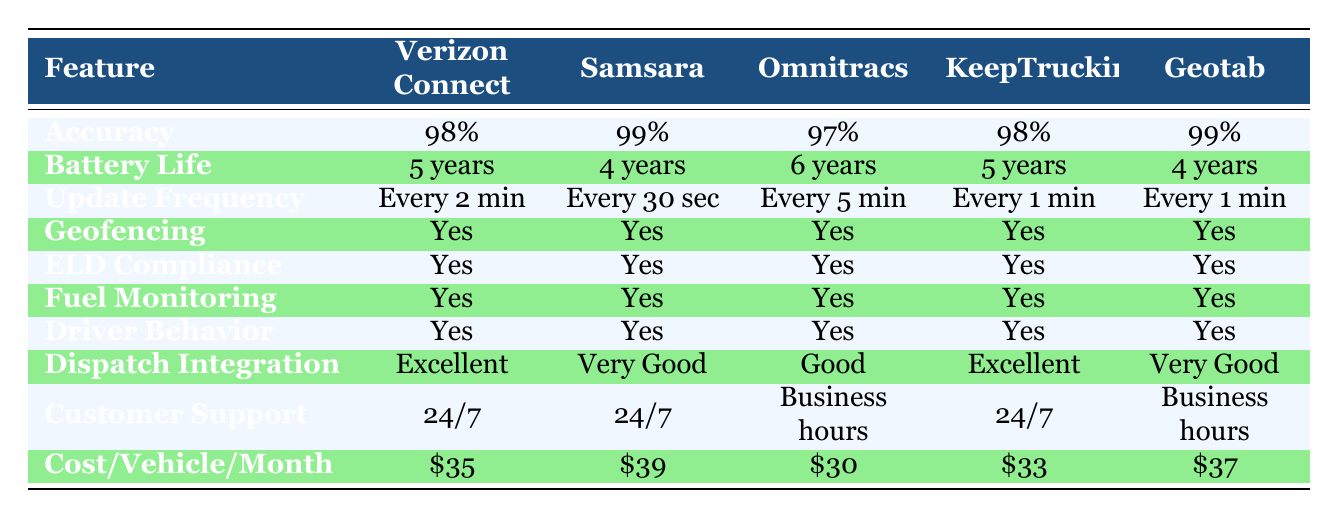What is the real-time tracking accuracy of Samsara? The table shows the real-time tracking accuracy for each GPS tracking system. Looking at the Samsara row, I see that its accuracy is listed as 99%.
Answer: 99% Which GPS system has the longest battery life? To determine which GPS system has the longest battery life, I compare the battery life values across all brands. The table shows that Omnitracs has a battery life of 6 years, which is longer than the others.
Answer: Omnitracs Is KeepTruckin ELD compliant? The table lists ELD compliance for each GPS tracking system. Looking at the KeepTruckin row, it states 'Yes' for ELD compliance, confirming it is compliant.
Answer: Yes Which GPS system provides updates every minute? By checking the update frequency for each GPS system, I can identify which ones provide updates every minute. The table shows that both KeepTruckin and Geotab have an update frequency of every 1 minute.
Answer: KeepTruckin and Geotab What is the cost per vehicle per month for the GPS system with the best customer support? I first locate the customer support quality for each system. The best quality is 'Excellent', found in the rows for Verizon Connect and KeepTruckin. Their costs are $35 and $33 respectively. Comparing these, KeepTruckin is cheaper at $33.
Answer: $33 How much more does Samsara cost per vehicle per month compared to Omnitracs? The cost per vehicle per month for Samsara is $39 and for Omnitracs it is $30. To find the difference, I subtract Omnitracs' cost from Samsara's cost: $39 - $30 = $9.
Answer: $9 Are any GPS tracking systems lacking geofencing capability? I check the geofencing capability column for each GPS system. The table indicates that all GPS systems have 'Yes' marked for geofencing capability, meaning none lack this feature.
Answer: No Which GPS tracking system has the lowest cost per vehicle per month among those with 24/7 customer support? I look at customer support quality and find that Verizon Connect, Samsara, and KeepTruckin provide 24/7 customer support. Their costs are $35, $39, and $33 respectively. The lowest cost among them is KeepTruckin at $33.
Answer: $33 What percentage of the GPS tracking systems have fuel monitoring capabilities? I check the fuel monitoring capability for each system. All 5 systems have 'Yes' for fuel monitoring. To find the percentage, I calculate (5/5) * 100 = 100%.
Answer: 100% 